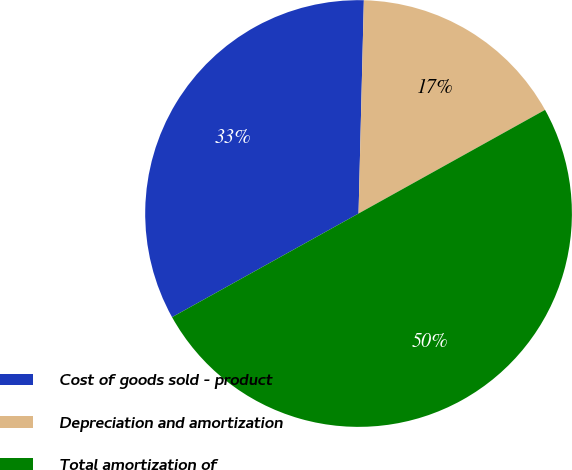Convert chart to OTSL. <chart><loc_0><loc_0><loc_500><loc_500><pie_chart><fcel>Cost of goods sold - product<fcel>Depreciation and amortization<fcel>Total amortization of<nl><fcel>33.47%<fcel>16.53%<fcel>50.0%<nl></chart> 